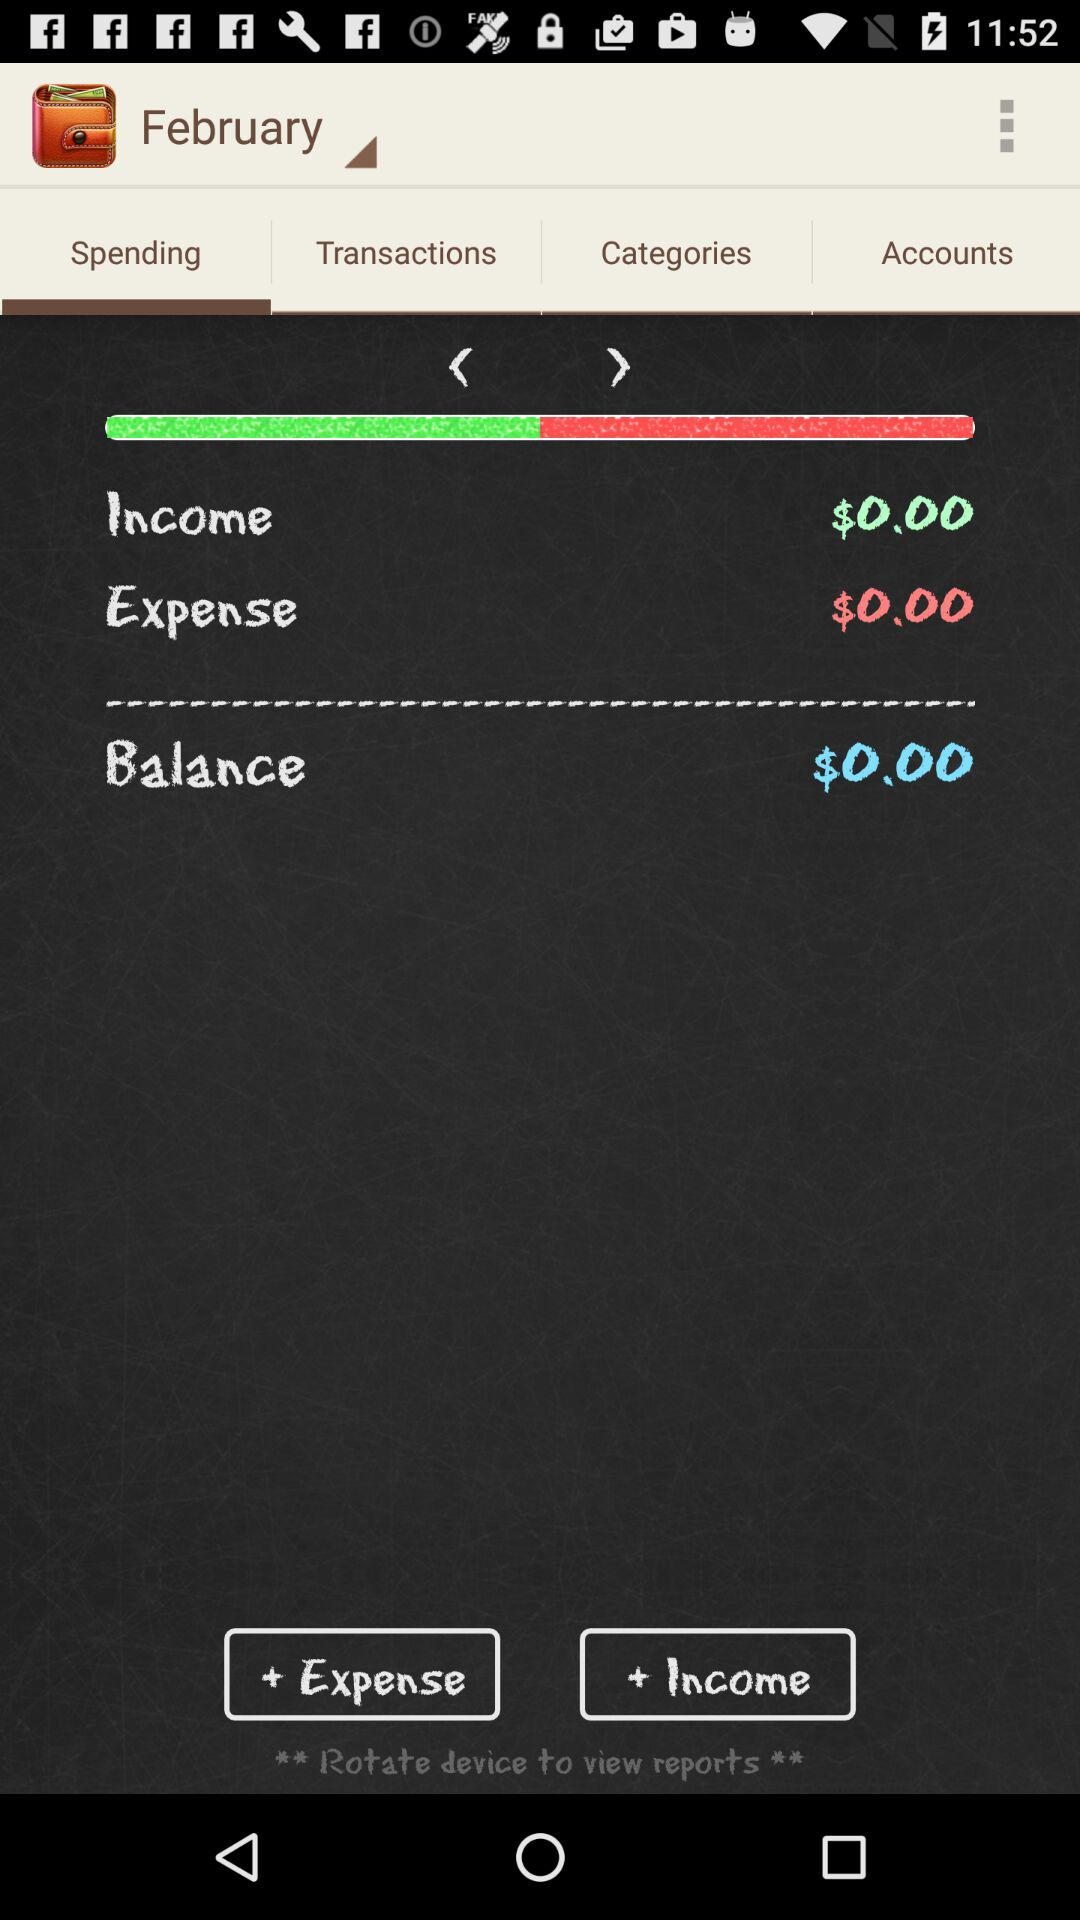How much money is in the balance?
Answer the question using a single word or phrase. $0.00 